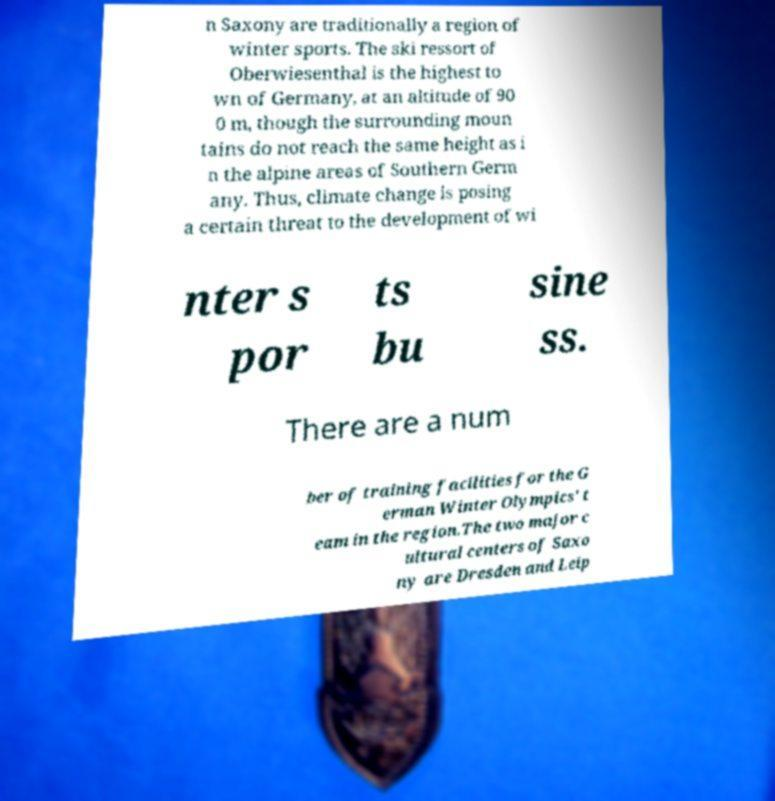Could you extract and type out the text from this image? n Saxony are traditionally a region of winter sports. The ski ressort of Oberwiesenthal is the highest to wn of Germany, at an altitude of 90 0 m, though the surrounding moun tains do not reach the same height as i n the alpine areas of Southern Germ any. Thus, climate change is posing a certain threat to the development of wi nter s por ts bu sine ss. There are a num ber of training facilities for the G erman Winter Olympics' t eam in the region.The two major c ultural centers of Saxo ny are Dresden and Leip 